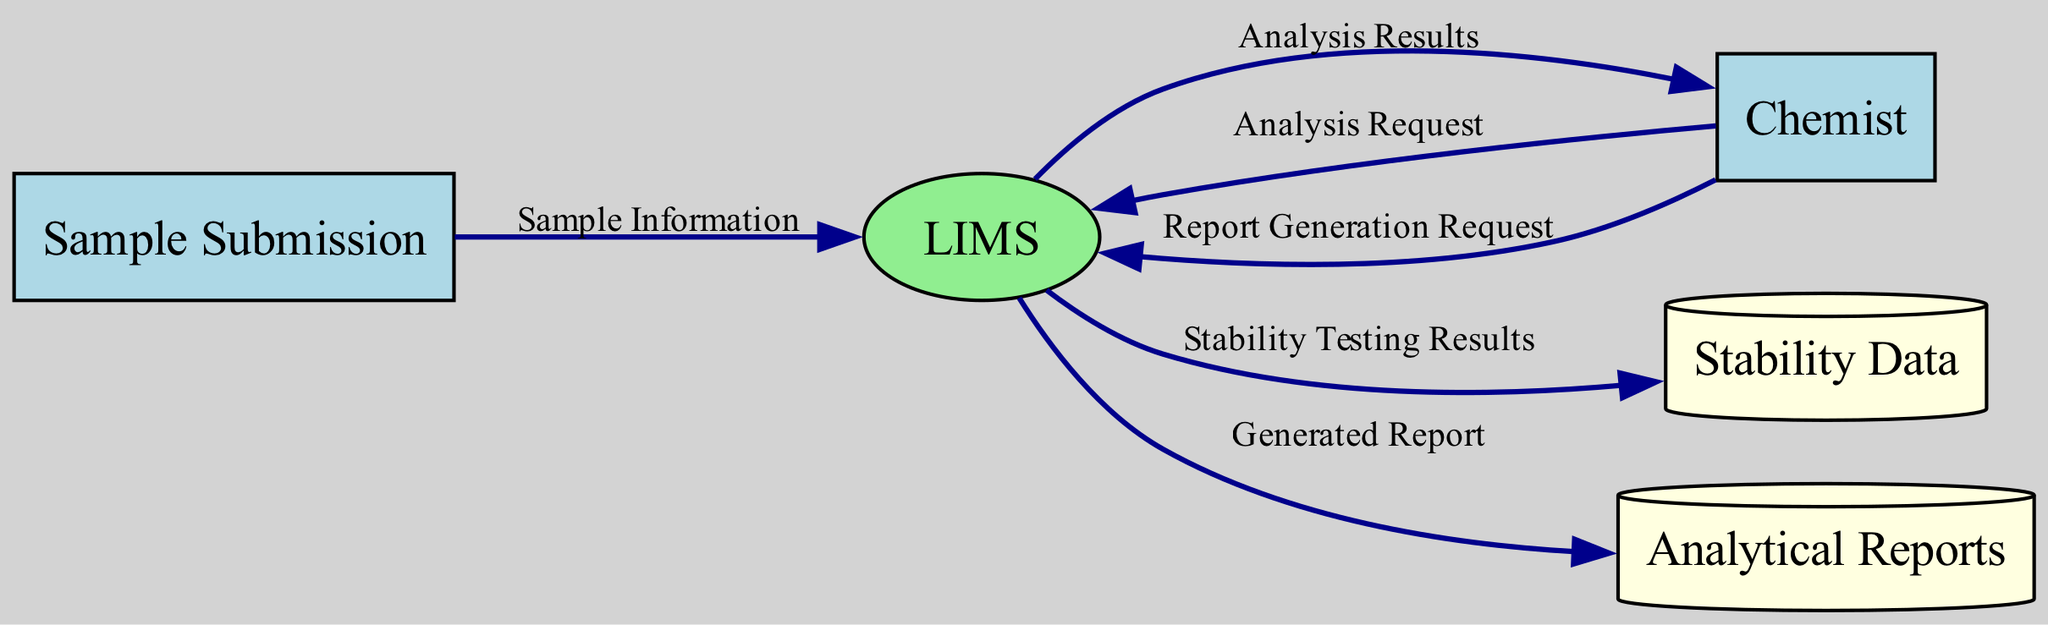What is the external entity where samples are submitted for analysis? The external entity for sample submission is named "Sample Submission". It is the initial point in the data flow where samples enter the system for subsequent analysis processes.
Answer: Sample Submission How many external entities are present in the diagram? In the diagram, there are two external entities: "Sample Submission" and "Chemist". Both entities interact with the Laboratory Information Management System (LIMS) to facilitate analysis activities.
Answer: 2 What type of data flow represents the request for analysis tests? The data flow that indicates the request for analysis tests is labeled "Analysis Request". This flow moves from the "Chemist" to the "LIMS", specifying the tests to be performed on the submitted samples.
Answer: Analysis Request Which entity is responsible for storing the stability testing data? The entity responsible for storing stability testing data is identified as "Stability Data". It acts as a repository where all relevant stability testing results are archived.
Answer: Stability Data What is the final output created based on analysis results and stability data? The final output created is termed "Generated Report". It compiles the findings from both the analysis results and any stability tests conducted, forming a comprehensive document.
Answer: Generated Report What is the relationship between "LIMS" and "Stability Testing Results"? The "LIMS" process produces outputs labeled as "Stability Testing Results", which flow into the data store "Stability Data". This implies that LIMS processes and archives stability test results accordingly.
Answer: Produces results How many data flows originate from the "Chemist"? There are three data flows originating from the "Chemist": "Analysis Request", "Report Generation Request", and the flow that receives "Analysis Results". These flows denote the chemist's activities and interactions with the LIMS.
Answer: 3 What is stored in the "Analytical Reports" data store? The "Analytical Reports" data store serves as an archive for the various generated reports based on the analysis and stability testing results, keeping a record of all finalized documents.
Answer: Analytical reports Which external entity performs analyses and tests on the samples? The external entity that performs analyses on the samples is the "Chemist". The chemist engages actively in the testing procedures and interacts with the LIMS accordingly.
Answer: Chemist 